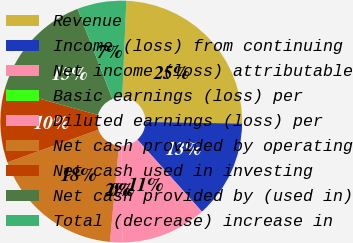Convert chart to OTSL. <chart><loc_0><loc_0><loc_500><loc_500><pie_chart><fcel>Revenue<fcel>Income (loss) from continuing<fcel>Net income (loss) attributable<fcel>Basic earnings (loss) per<fcel>Diluted earnings (loss) per<fcel>Net cash provided by operating<fcel>Net cash used in investing<fcel>Net cash provided by (used in)<fcel>Total (decrease) increase in<nl><fcel>24.59%<fcel>13.11%<fcel>11.48%<fcel>0.0%<fcel>1.64%<fcel>18.03%<fcel>9.84%<fcel>14.75%<fcel>6.56%<nl></chart> 